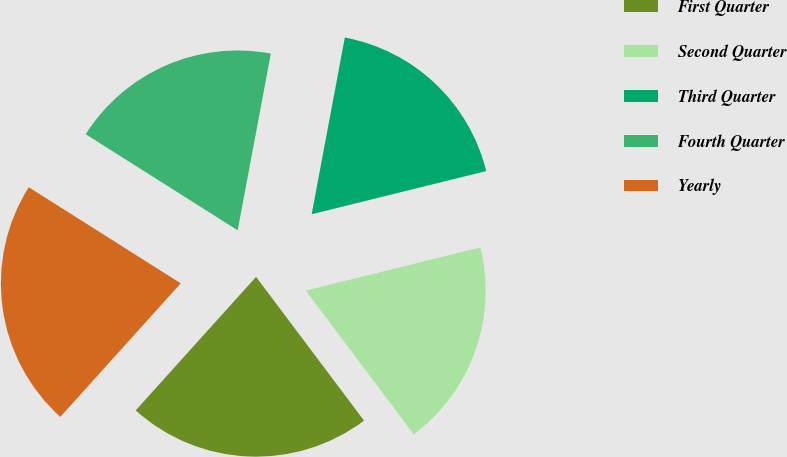Convert chart. <chart><loc_0><loc_0><loc_500><loc_500><pie_chart><fcel>First Quarter<fcel>Second Quarter<fcel>Third Quarter<fcel>Fourth Quarter<fcel>Yearly<nl><fcel>21.93%<fcel>18.61%<fcel>18.19%<fcel>18.98%<fcel>22.3%<nl></chart> 